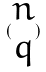<formula> <loc_0><loc_0><loc_500><loc_500>( \begin{matrix} n \\ q \end{matrix} )</formula> 